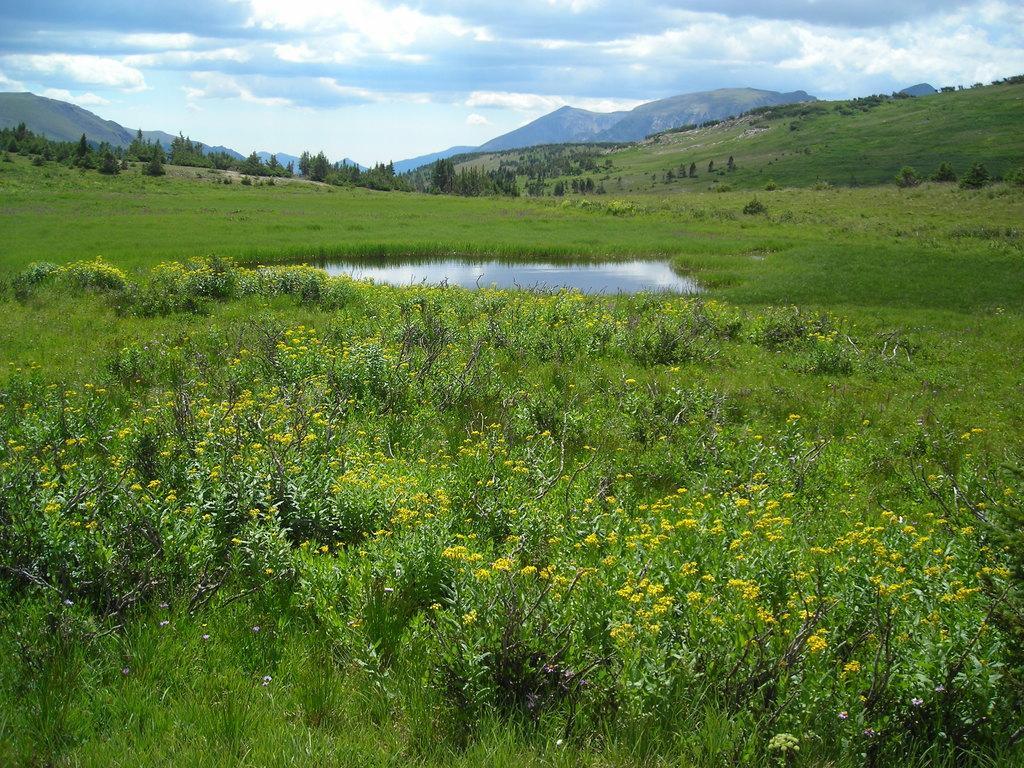How would you summarize this image in a sentence or two? In this image in the foreground there are many flower plants. Here there is a water body. In the background there are hills, trees. The sky is cloudy. 